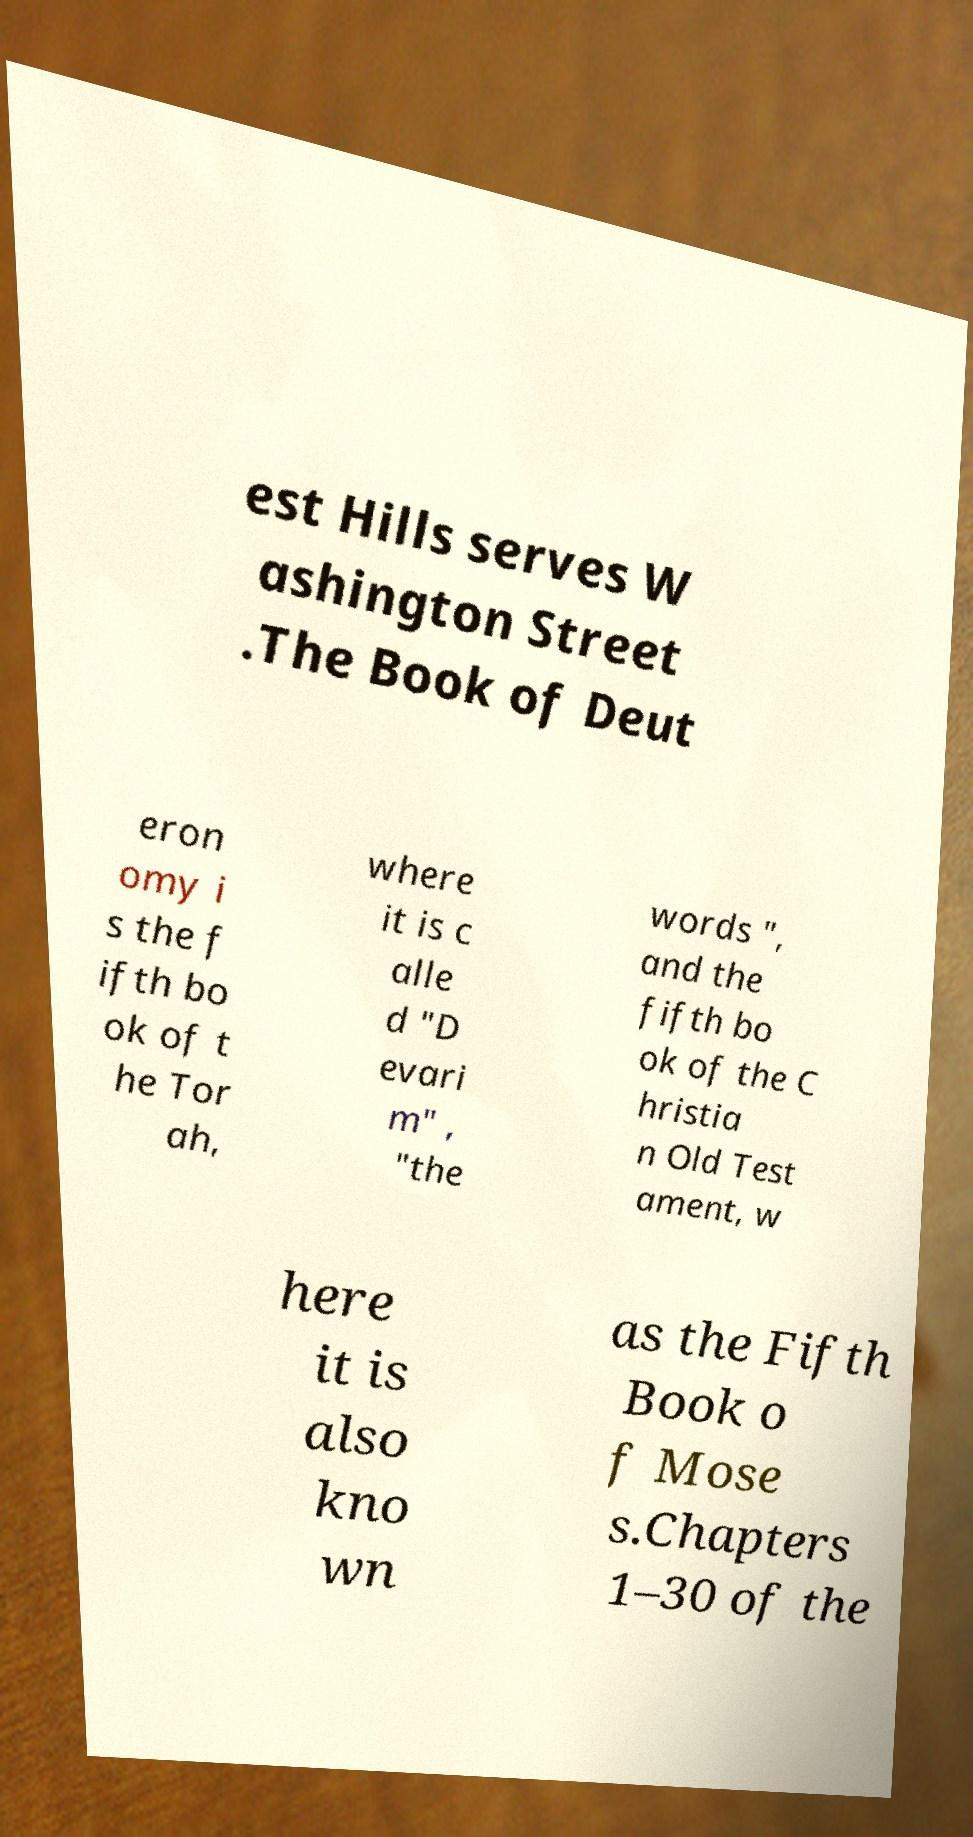Can you accurately transcribe the text from the provided image for me? est Hills serves W ashington Street .The Book of Deut eron omy i s the f ifth bo ok of t he Tor ah, where it is c alle d "D evari m" , "the words ", and the fifth bo ok of the C hristia n Old Test ament, w here it is also kno wn as the Fifth Book o f Mose s.Chapters 1–30 of the 